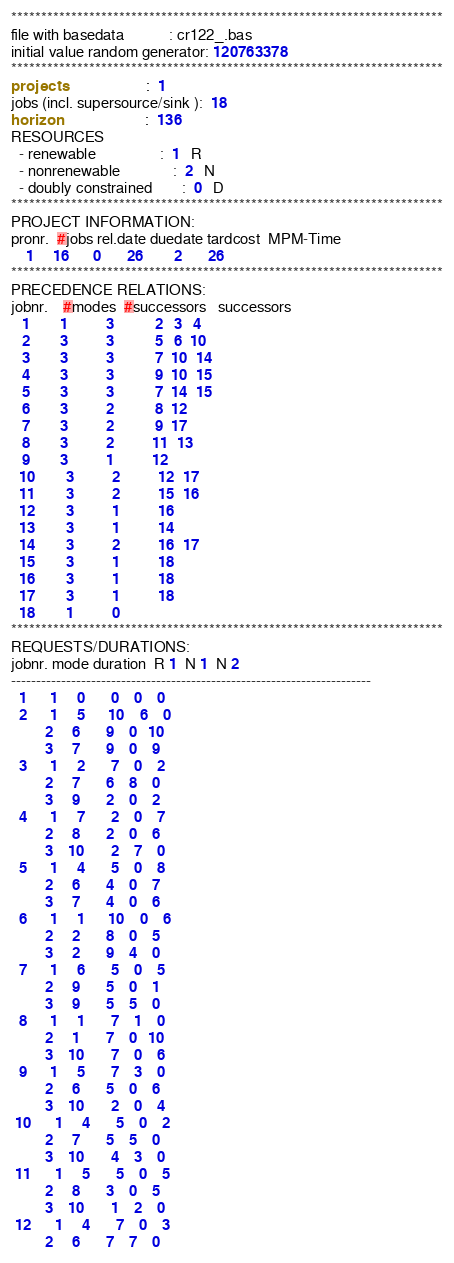<code> <loc_0><loc_0><loc_500><loc_500><_ObjectiveC_>************************************************************************
file with basedata            : cr122_.bas
initial value random generator: 120763378
************************************************************************
projects                      :  1
jobs (incl. supersource/sink ):  18
horizon                       :  136
RESOURCES
  - renewable                 :  1   R
  - nonrenewable              :  2   N
  - doubly constrained        :  0   D
************************************************************************
PROJECT INFORMATION:
pronr.  #jobs rel.date duedate tardcost  MPM-Time
    1     16      0       26        2       26
************************************************************************
PRECEDENCE RELATIONS:
jobnr.    #modes  #successors   successors
   1        1          3           2   3   4
   2        3          3           5   6  10
   3        3          3           7  10  14
   4        3          3           9  10  15
   5        3          3           7  14  15
   6        3          2           8  12
   7        3          2           9  17
   8        3          2          11  13
   9        3          1          12
  10        3          2          12  17
  11        3          2          15  16
  12        3          1          16
  13        3          1          14
  14        3          2          16  17
  15        3          1          18
  16        3          1          18
  17        3          1          18
  18        1          0        
************************************************************************
REQUESTS/DURATIONS:
jobnr. mode duration  R 1  N 1  N 2
------------------------------------------------------------------------
  1      1     0       0    0    0
  2      1     5      10    6    0
         2     6       9    0   10
         3     7       9    0    9
  3      1     2       7    0    2
         2     7       6    8    0
         3     9       2    0    2
  4      1     7       2    0    7
         2     8       2    0    6
         3    10       2    7    0
  5      1     4       5    0    8
         2     6       4    0    7
         3     7       4    0    6
  6      1     1      10    0    6
         2     2       8    0    5
         3     2       9    4    0
  7      1     6       5    0    5
         2     9       5    0    1
         3     9       5    5    0
  8      1     1       7    1    0
         2     1       7    0   10
         3    10       7    0    6
  9      1     5       7    3    0
         2     6       5    0    6
         3    10       2    0    4
 10      1     4       5    0    2
         2     7       5    5    0
         3    10       4    3    0
 11      1     5       5    0    5
         2     8       3    0    5
         3    10       1    2    0
 12      1     4       7    0    3
         2     6       7    7    0</code> 